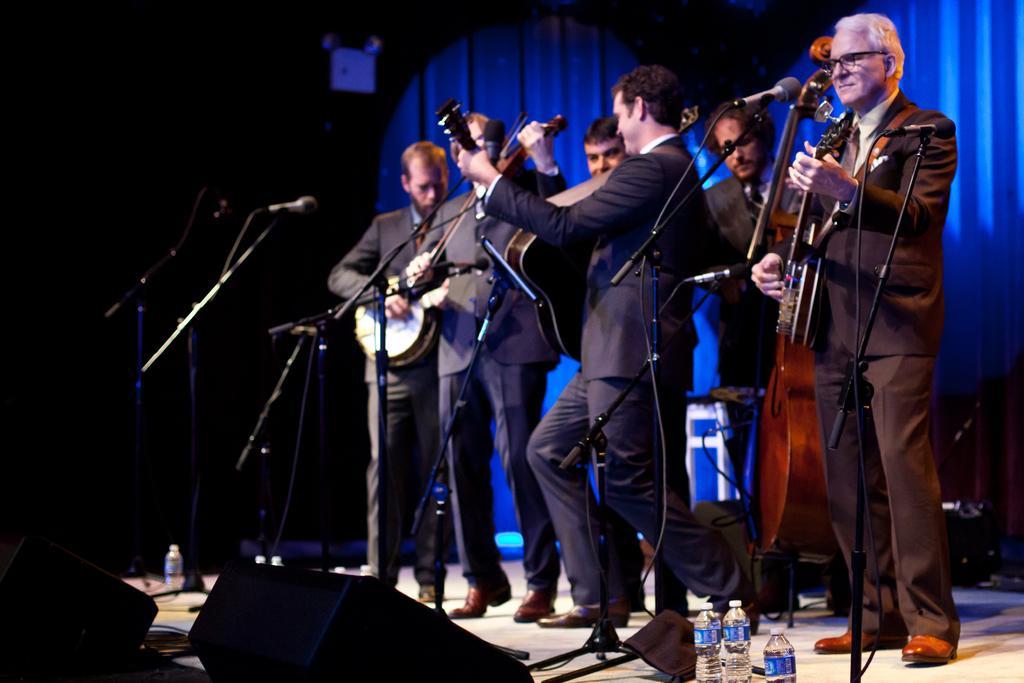Can you describe this image briefly? This is a picture taken in a hall, there are group of people holding the music instruments standing on a stage. In front of the people there is a microphones with stands on the stage there are the water bottles and cables. Background of this people is a curtain which is a blue color. 